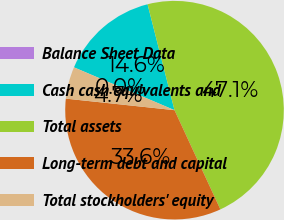<chart> <loc_0><loc_0><loc_500><loc_500><pie_chart><fcel>Balance Sheet Data<fcel>Cash cash equivalents and<fcel>Total assets<fcel>Long-term debt and capital<fcel>Total stockholders' equity<nl><fcel>0.01%<fcel>14.62%<fcel>47.08%<fcel>33.58%<fcel>4.72%<nl></chart> 